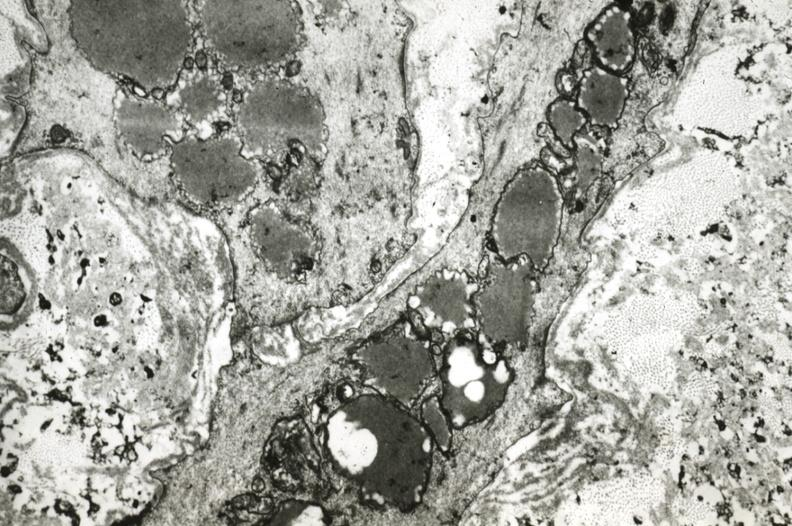s lower chest and abdomen anterior present?
Answer the question using a single word or phrase. No 